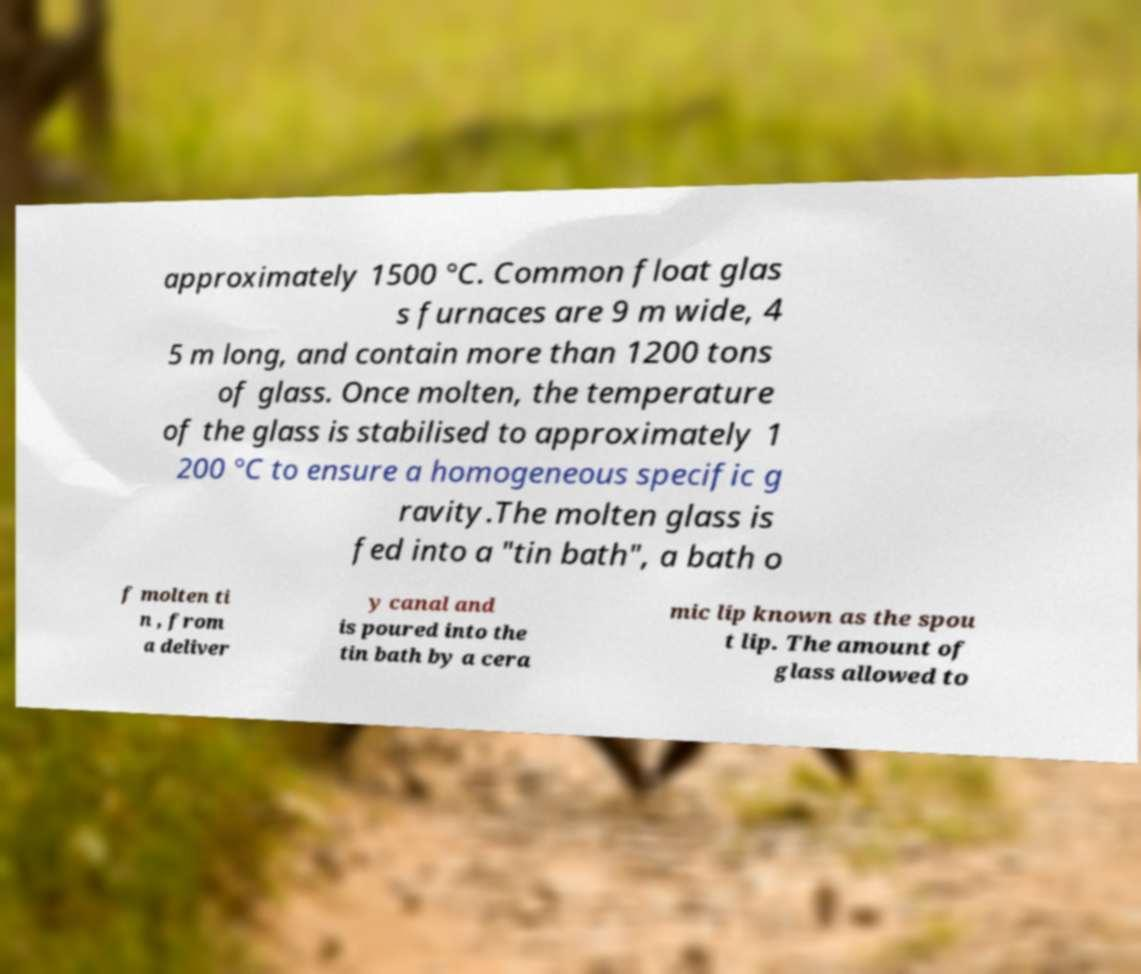For documentation purposes, I need the text within this image transcribed. Could you provide that? approximately 1500 °C. Common float glas s furnaces are 9 m wide, 4 5 m long, and contain more than 1200 tons of glass. Once molten, the temperature of the glass is stabilised to approximately 1 200 °C to ensure a homogeneous specific g ravity.The molten glass is fed into a "tin bath", a bath o f molten ti n , from a deliver y canal and is poured into the tin bath by a cera mic lip known as the spou t lip. The amount of glass allowed to 